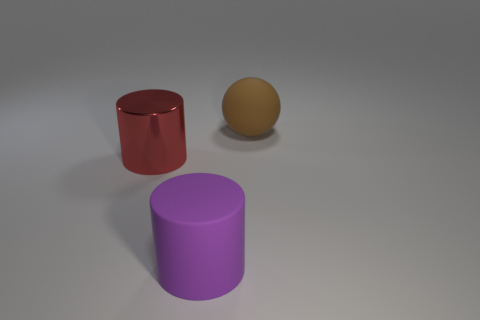What number of objects are the same color as the large metallic cylinder?
Your answer should be very brief. 0. Is the purple rubber object the same size as the brown thing?
Your answer should be compact. Yes. What material is the purple cylinder?
Offer a very short reply. Rubber. What is the color of the other object that is the same material as the large brown thing?
Offer a terse response. Purple. Does the large brown thing have the same material as the big cylinder that is to the right of the shiny cylinder?
Your response must be concise. Yes. How many large cylinders have the same material as the ball?
Provide a short and direct response. 1. What shape is the large rubber object that is in front of the rubber ball?
Offer a terse response. Cylinder. Do the large thing behind the large metal object and the large cylinder that is on the right side of the large metallic cylinder have the same material?
Your response must be concise. Yes. Is there another big purple metal thing that has the same shape as the purple thing?
Keep it short and to the point. No. What number of objects are rubber things that are in front of the red cylinder or big rubber things?
Your answer should be compact. 2. 